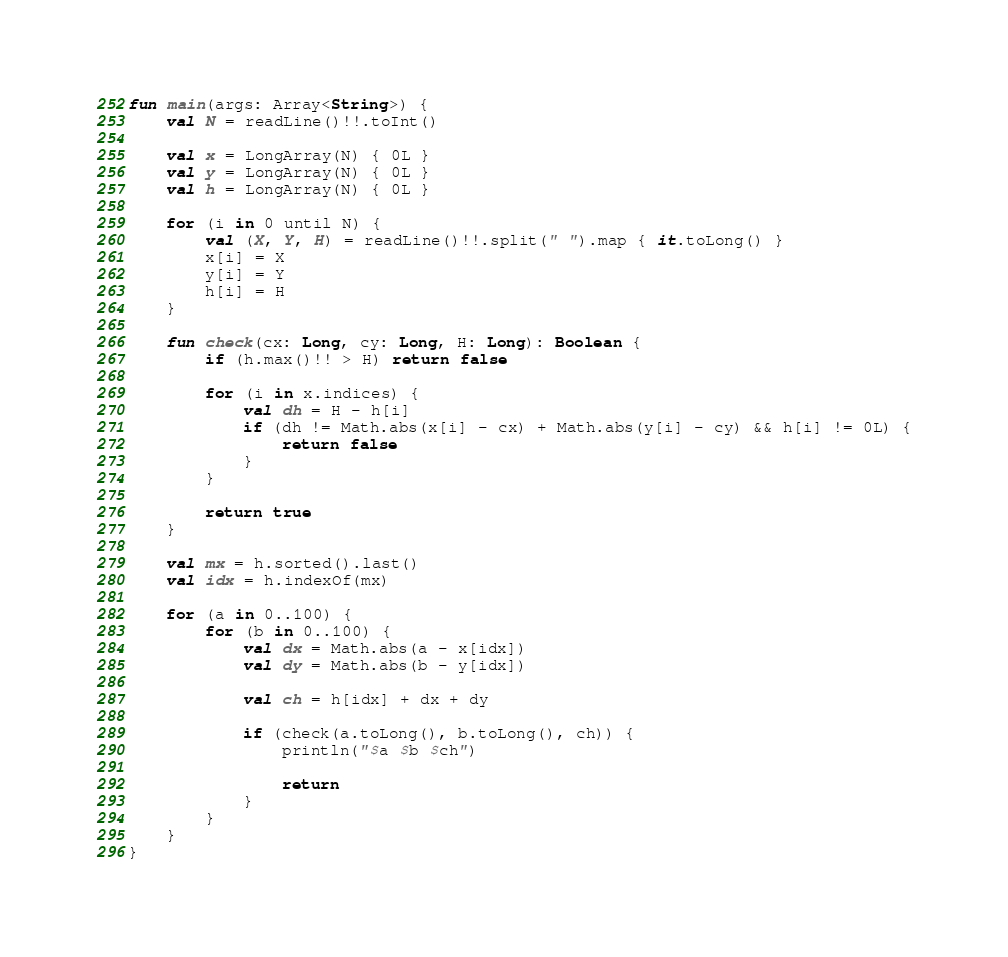Convert code to text. <code><loc_0><loc_0><loc_500><loc_500><_Kotlin_>fun main(args: Array<String>) {
    val N = readLine()!!.toInt()

    val x = LongArray(N) { 0L }
    val y = LongArray(N) { 0L }
    val h = LongArray(N) { 0L }

    for (i in 0 until N) {
        val (X, Y, H) = readLine()!!.split(" ").map { it.toLong() }
        x[i] = X
        y[i] = Y
        h[i] = H
    }

    fun check(cx: Long, cy: Long, H: Long): Boolean {
        if (h.max()!! > H) return false

        for (i in x.indices) {
            val dh = H - h[i]
            if (dh != Math.abs(x[i] - cx) + Math.abs(y[i] - cy) && h[i] != 0L) {
                return false
            }
        }

        return true
    }

    val mx = h.sorted().last()
    val idx = h.indexOf(mx)

    for (a in 0..100) {
        for (b in 0..100) {
            val dx = Math.abs(a - x[idx])
            val dy = Math.abs(b - y[idx])

            val ch = h[idx] + dx + dy

            if (check(a.toLong(), b.toLong(), ch)) {
                println("$a $b $ch")

                return
            }
        }
    }
}
</code> 